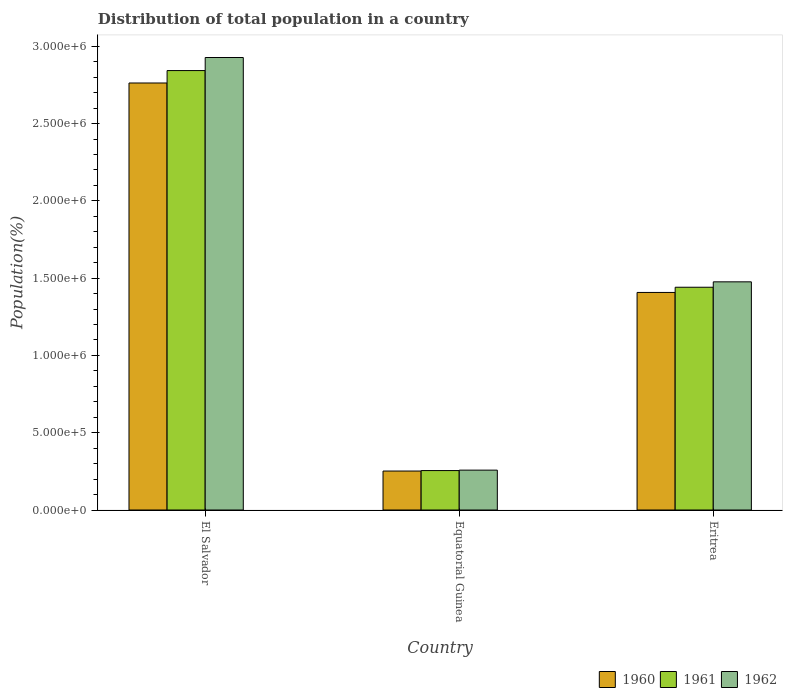How many bars are there on the 2nd tick from the right?
Offer a very short reply. 3. What is the label of the 3rd group of bars from the left?
Offer a very short reply. Eritrea. What is the population of in 1961 in Eritrea?
Keep it short and to the point. 1.44e+06. Across all countries, what is the maximum population of in 1961?
Your answer should be compact. 2.84e+06. Across all countries, what is the minimum population of in 1962?
Keep it short and to the point. 2.58e+05. In which country was the population of in 1960 maximum?
Provide a succinct answer. El Salvador. In which country was the population of in 1962 minimum?
Ensure brevity in your answer.  Equatorial Guinea. What is the total population of in 1960 in the graph?
Provide a succinct answer. 4.42e+06. What is the difference between the population of in 1962 in El Salvador and that in Equatorial Guinea?
Offer a very short reply. 2.67e+06. What is the difference between the population of in 1961 in Eritrea and the population of in 1962 in El Salvador?
Offer a terse response. -1.49e+06. What is the average population of in 1962 per country?
Keep it short and to the point. 1.55e+06. What is the difference between the population of of/in 1961 and population of of/in 1962 in Eritrea?
Keep it short and to the point. -3.50e+04. What is the ratio of the population of in 1961 in El Salvador to that in Eritrea?
Make the answer very short. 1.97. Is the difference between the population of in 1961 in El Salvador and Equatorial Guinea greater than the difference between the population of in 1962 in El Salvador and Equatorial Guinea?
Give a very brief answer. No. What is the difference between the highest and the second highest population of in 1962?
Your response must be concise. 1.22e+06. What is the difference between the highest and the lowest population of in 1961?
Your response must be concise. 2.59e+06. What does the 3rd bar from the left in Eritrea represents?
Your response must be concise. 1962. Is it the case that in every country, the sum of the population of in 1961 and population of in 1960 is greater than the population of in 1962?
Your answer should be very brief. Yes. How many bars are there?
Your answer should be compact. 9. What is the difference between two consecutive major ticks on the Y-axis?
Your answer should be very brief. 5.00e+05. Does the graph contain any zero values?
Ensure brevity in your answer.  No. Where does the legend appear in the graph?
Provide a short and direct response. Bottom right. How many legend labels are there?
Your answer should be very brief. 3. How are the legend labels stacked?
Offer a terse response. Horizontal. What is the title of the graph?
Your response must be concise. Distribution of total population in a country. What is the label or title of the Y-axis?
Your answer should be compact. Population(%). What is the Population(%) of 1960 in El Salvador?
Make the answer very short. 2.76e+06. What is the Population(%) of 1961 in El Salvador?
Your response must be concise. 2.84e+06. What is the Population(%) in 1962 in El Salvador?
Offer a terse response. 2.93e+06. What is the Population(%) in 1960 in Equatorial Guinea?
Provide a succinct answer. 2.52e+05. What is the Population(%) in 1961 in Equatorial Guinea?
Make the answer very short. 2.55e+05. What is the Population(%) in 1962 in Equatorial Guinea?
Offer a very short reply. 2.58e+05. What is the Population(%) of 1960 in Eritrea?
Your response must be concise. 1.41e+06. What is the Population(%) in 1961 in Eritrea?
Your answer should be very brief. 1.44e+06. What is the Population(%) of 1962 in Eritrea?
Your answer should be compact. 1.48e+06. Across all countries, what is the maximum Population(%) in 1960?
Provide a short and direct response. 2.76e+06. Across all countries, what is the maximum Population(%) of 1961?
Ensure brevity in your answer.  2.84e+06. Across all countries, what is the maximum Population(%) in 1962?
Offer a terse response. 2.93e+06. Across all countries, what is the minimum Population(%) in 1960?
Your answer should be compact. 2.52e+05. Across all countries, what is the minimum Population(%) of 1961?
Give a very brief answer. 2.55e+05. Across all countries, what is the minimum Population(%) in 1962?
Provide a short and direct response. 2.58e+05. What is the total Population(%) in 1960 in the graph?
Your answer should be compact. 4.42e+06. What is the total Population(%) of 1961 in the graph?
Your answer should be compact. 4.54e+06. What is the total Population(%) of 1962 in the graph?
Keep it short and to the point. 4.66e+06. What is the difference between the Population(%) in 1960 in El Salvador and that in Equatorial Guinea?
Keep it short and to the point. 2.51e+06. What is the difference between the Population(%) of 1961 in El Salvador and that in Equatorial Guinea?
Your response must be concise. 2.59e+06. What is the difference between the Population(%) in 1962 in El Salvador and that in Equatorial Guinea?
Give a very brief answer. 2.67e+06. What is the difference between the Population(%) of 1960 in El Salvador and that in Eritrea?
Your answer should be very brief. 1.36e+06. What is the difference between the Population(%) in 1961 in El Salvador and that in Eritrea?
Give a very brief answer. 1.40e+06. What is the difference between the Population(%) in 1962 in El Salvador and that in Eritrea?
Give a very brief answer. 1.45e+06. What is the difference between the Population(%) in 1960 in Equatorial Guinea and that in Eritrea?
Give a very brief answer. -1.16e+06. What is the difference between the Population(%) of 1961 in Equatorial Guinea and that in Eritrea?
Make the answer very short. -1.19e+06. What is the difference between the Population(%) in 1962 in Equatorial Guinea and that in Eritrea?
Make the answer very short. -1.22e+06. What is the difference between the Population(%) in 1960 in El Salvador and the Population(%) in 1961 in Equatorial Guinea?
Keep it short and to the point. 2.51e+06. What is the difference between the Population(%) of 1960 in El Salvador and the Population(%) of 1962 in Equatorial Guinea?
Your answer should be compact. 2.50e+06. What is the difference between the Population(%) of 1961 in El Salvador and the Population(%) of 1962 in Equatorial Guinea?
Offer a very short reply. 2.59e+06. What is the difference between the Population(%) in 1960 in El Salvador and the Population(%) in 1961 in Eritrea?
Your response must be concise. 1.32e+06. What is the difference between the Population(%) of 1960 in El Salvador and the Population(%) of 1962 in Eritrea?
Make the answer very short. 1.29e+06. What is the difference between the Population(%) in 1961 in El Salvador and the Population(%) in 1962 in Eritrea?
Your response must be concise. 1.37e+06. What is the difference between the Population(%) in 1960 in Equatorial Guinea and the Population(%) in 1961 in Eritrea?
Make the answer very short. -1.19e+06. What is the difference between the Population(%) in 1960 in Equatorial Guinea and the Population(%) in 1962 in Eritrea?
Ensure brevity in your answer.  -1.22e+06. What is the difference between the Population(%) in 1961 in Equatorial Guinea and the Population(%) in 1962 in Eritrea?
Offer a very short reply. -1.22e+06. What is the average Population(%) in 1960 per country?
Provide a succinct answer. 1.47e+06. What is the average Population(%) of 1961 per country?
Make the answer very short. 1.51e+06. What is the average Population(%) in 1962 per country?
Give a very brief answer. 1.55e+06. What is the difference between the Population(%) in 1960 and Population(%) in 1961 in El Salvador?
Ensure brevity in your answer.  -8.03e+04. What is the difference between the Population(%) of 1960 and Population(%) of 1962 in El Salvador?
Provide a succinct answer. -1.65e+05. What is the difference between the Population(%) in 1961 and Population(%) in 1962 in El Salvador?
Your response must be concise. -8.46e+04. What is the difference between the Population(%) in 1960 and Population(%) in 1961 in Equatorial Guinea?
Provide a short and direct response. -2985. What is the difference between the Population(%) of 1960 and Population(%) of 1962 in Equatorial Guinea?
Provide a succinct answer. -5825. What is the difference between the Population(%) of 1961 and Population(%) of 1962 in Equatorial Guinea?
Offer a terse response. -2840. What is the difference between the Population(%) in 1960 and Population(%) in 1961 in Eritrea?
Your answer should be very brief. -3.37e+04. What is the difference between the Population(%) in 1960 and Population(%) in 1962 in Eritrea?
Your answer should be very brief. -6.87e+04. What is the difference between the Population(%) in 1961 and Population(%) in 1962 in Eritrea?
Make the answer very short. -3.50e+04. What is the ratio of the Population(%) in 1960 in El Salvador to that in Equatorial Guinea?
Your response must be concise. 10.96. What is the ratio of the Population(%) in 1961 in El Salvador to that in Equatorial Guinea?
Offer a terse response. 11.15. What is the ratio of the Population(%) of 1962 in El Salvador to that in Equatorial Guinea?
Keep it short and to the point. 11.35. What is the ratio of the Population(%) of 1960 in El Salvador to that in Eritrea?
Offer a terse response. 1.96. What is the ratio of the Population(%) in 1961 in El Salvador to that in Eritrea?
Offer a terse response. 1.97. What is the ratio of the Population(%) of 1962 in El Salvador to that in Eritrea?
Keep it short and to the point. 1.98. What is the ratio of the Population(%) in 1960 in Equatorial Guinea to that in Eritrea?
Ensure brevity in your answer.  0.18. What is the ratio of the Population(%) in 1961 in Equatorial Guinea to that in Eritrea?
Offer a very short reply. 0.18. What is the ratio of the Population(%) of 1962 in Equatorial Guinea to that in Eritrea?
Your response must be concise. 0.17. What is the difference between the highest and the second highest Population(%) of 1960?
Give a very brief answer. 1.36e+06. What is the difference between the highest and the second highest Population(%) of 1961?
Provide a short and direct response. 1.40e+06. What is the difference between the highest and the second highest Population(%) in 1962?
Provide a succinct answer. 1.45e+06. What is the difference between the highest and the lowest Population(%) in 1960?
Provide a short and direct response. 2.51e+06. What is the difference between the highest and the lowest Population(%) in 1961?
Make the answer very short. 2.59e+06. What is the difference between the highest and the lowest Population(%) in 1962?
Ensure brevity in your answer.  2.67e+06. 